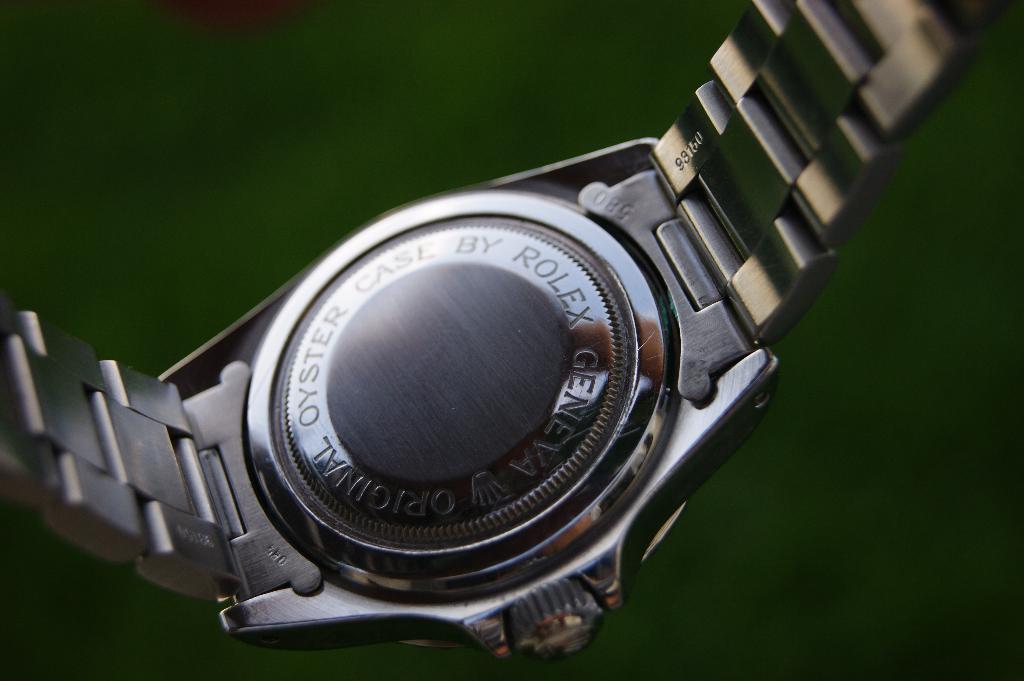What brand name is visible?
Offer a very short reply. Rolex. 